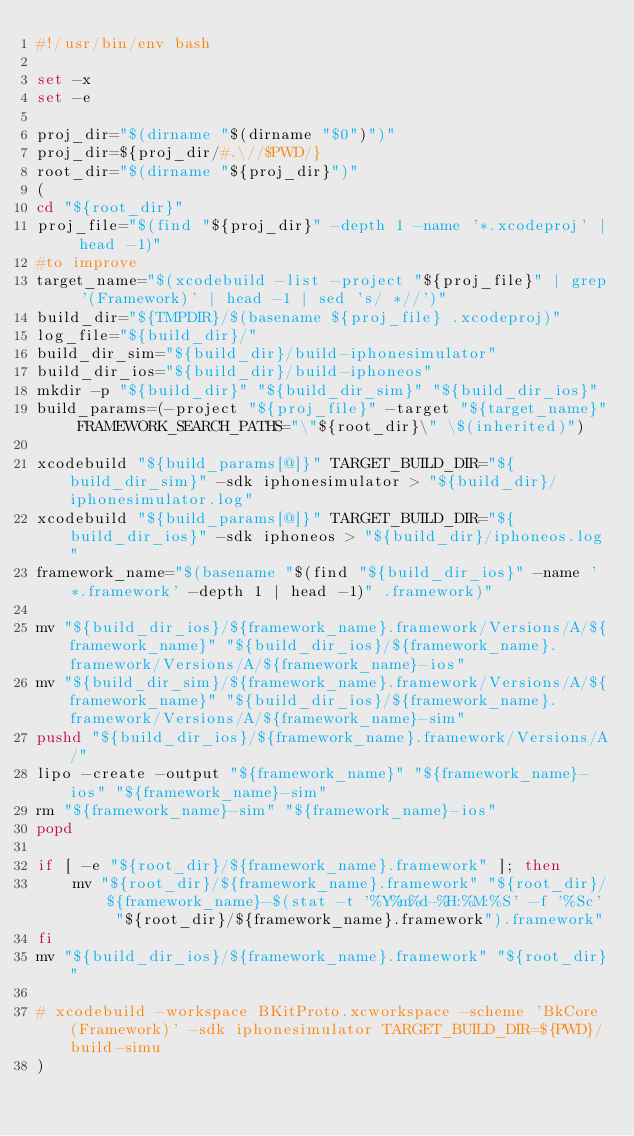Convert code to text. <code><loc_0><loc_0><loc_500><loc_500><_Bash_>#!/usr/bin/env bash

set -x
set -e

proj_dir="$(dirname "$(dirname "$0")")"
proj_dir=${proj_dir/#.\//$PWD/}
root_dir="$(dirname "${proj_dir}")"
(
cd "${root_dir}"
proj_file="$(find "${proj_dir}" -depth 1 -name '*.xcodeproj' | head -1)"
#to improve
target_name="$(xcodebuild -list -project "${proj_file}" | grep '(Framework)' | head -1 | sed 's/ *//')"
build_dir="${TMPDIR}/$(basename ${proj_file} .xcodeproj)"
log_file="${build_dir}/"
build_dir_sim="${build_dir}/build-iphonesimulator"
build_dir_ios="${build_dir}/build-iphoneos"
mkdir -p "${build_dir}" "${build_dir_sim}" "${build_dir_ios}"
build_params=(-project "${proj_file}" -target "${target_name}" FRAMEWORK_SEARCH_PATHS="\"${root_dir}\" \$(inherited)")

xcodebuild "${build_params[@]}" TARGET_BUILD_DIR="${build_dir_sim}" -sdk iphonesimulator > "${build_dir}/iphonesimulator.log"
xcodebuild "${build_params[@]}" TARGET_BUILD_DIR="${build_dir_ios}" -sdk iphoneos > "${build_dir}/iphoneos.log"
framework_name="$(basename "$(find "${build_dir_ios}" -name '*.framework' -depth 1 | head -1)" .framework)"

mv "${build_dir_ios}/${framework_name}.framework/Versions/A/${framework_name}" "${build_dir_ios}/${framework_name}.framework/Versions/A/${framework_name}-ios"
mv "${build_dir_sim}/${framework_name}.framework/Versions/A/${framework_name}" "${build_dir_ios}/${framework_name}.framework/Versions/A/${framework_name}-sim"
pushd "${build_dir_ios}/${framework_name}.framework/Versions/A/"
lipo -create -output "${framework_name}" "${framework_name}-ios" "${framework_name}-sim"
rm "${framework_name}-sim" "${framework_name}-ios"
popd

if [ -e "${root_dir}/${framework_name}.framework" ]; then
	mv "${root_dir}/${framework_name}.framework" "${root_dir}/${framework_name}-$(stat -t '%Y%m%d-%H:%M:%S' -f '%Sc' "${root_dir}/${framework_name}.framework").framework"
fi
mv "${build_dir_ios}/${framework_name}.framework" "${root_dir}"

# xcodebuild -workspace BKitProto.xcworkspace -scheme 'BkCore (Framework)' -sdk iphonesimulator TARGET_BUILD_DIR=${PWD}/build-simu
)
</code> 